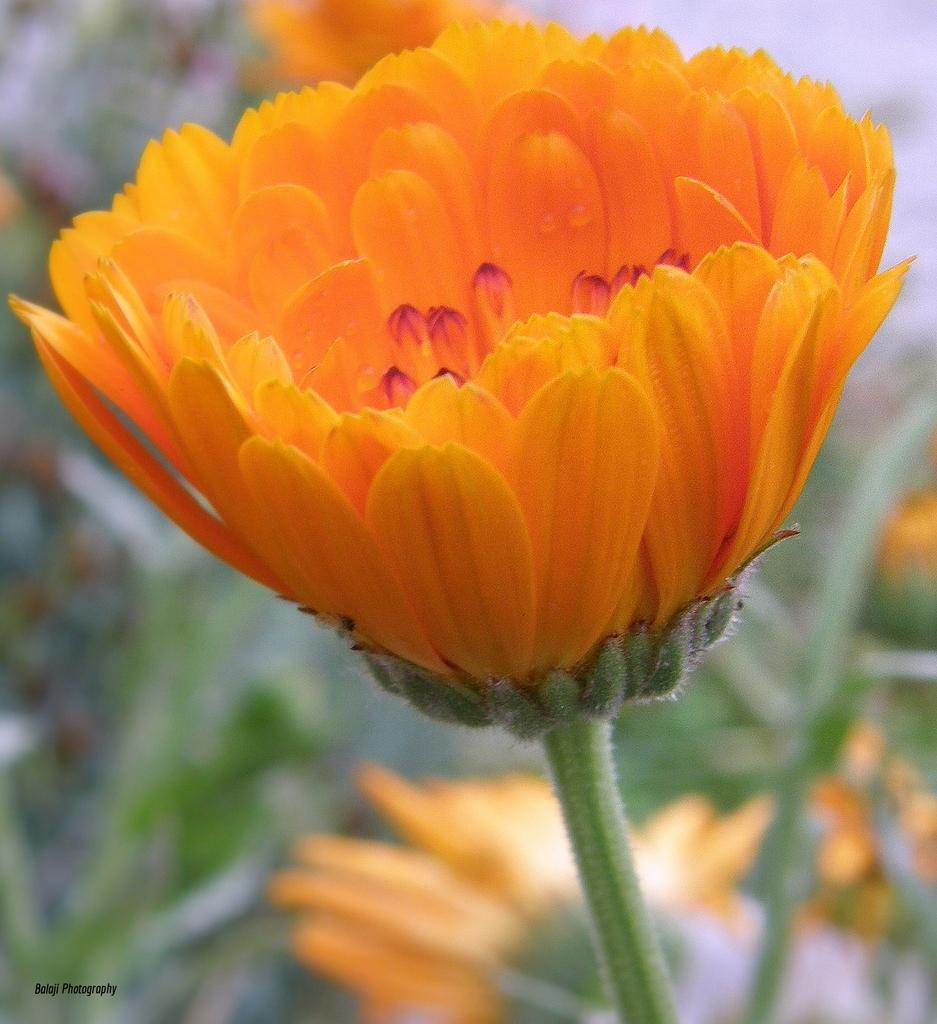What type of plants are visible in the image? There are plants with flowers in the image. Is there any text present in the image? Yes, there is some text at the bottom of the image. What type of goose can be seen in the scene depicted in the image? There is no goose present in the image; it features plants with flowers and some text. 